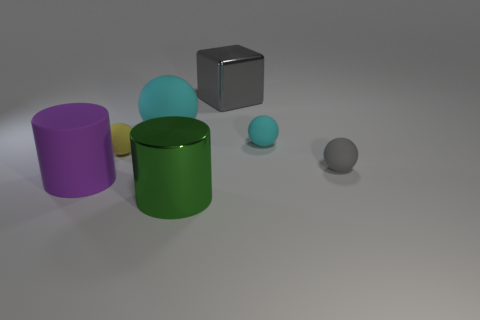There is a cyan matte sphere that is on the right side of the large green metal cylinder; does it have the same size as the gray thing in front of the big gray metallic cube?
Your response must be concise. Yes. What material is the object that is to the left of the small ball that is on the left side of the shiny cylinder?
Offer a very short reply. Rubber. Is the number of large balls behind the big gray metallic thing less than the number of tiny gray matte spheres?
Give a very brief answer. Yes. There is a yellow object that is made of the same material as the large sphere; what is its shape?
Your answer should be compact. Sphere. What number of other objects are the same shape as the small yellow object?
Give a very brief answer. 3. What number of brown objects are either metallic things or matte cylinders?
Your answer should be very brief. 0. Do the green shiny object and the big purple object have the same shape?
Keep it short and to the point. Yes. Is there a sphere to the left of the large metallic object in front of the gray metallic thing?
Your answer should be very brief. Yes. Is the number of purple cylinders that are to the left of the large purple thing the same as the number of big brown metallic cylinders?
Offer a very short reply. Yes. What number of other things are the same size as the purple matte thing?
Make the answer very short. 3. 